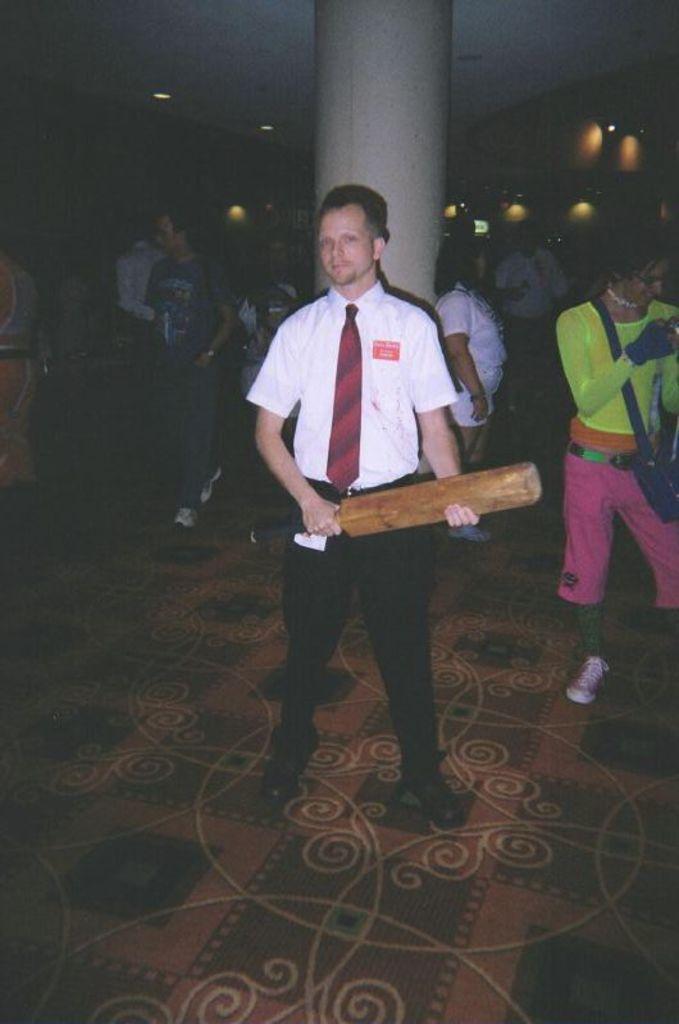Could you give a brief overview of what you see in this image? In this image there is a man standing on a floor, holding a bat in his hand and wearing a tie, in the background there are people standing and there is a pillar, at the top there is a ceiling and lights. 